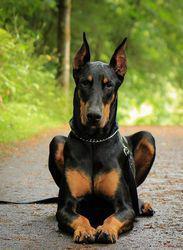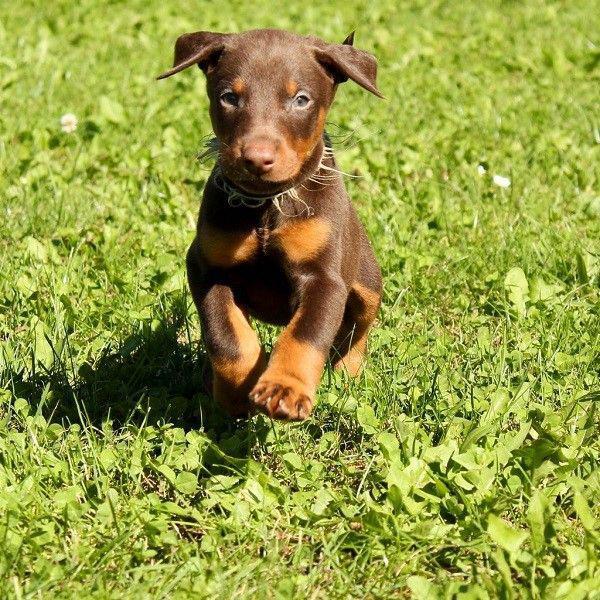The first image is the image on the left, the second image is the image on the right. Examine the images to the left and right. Is the description "One of the dobermans pictures has a black coat and one has a brown coat." accurate? Answer yes or no. Yes. The first image is the image on the left, the second image is the image on the right. Assess this claim about the two images: "All of the dogs are facing directly to the camera.". Correct or not? Answer yes or no. Yes. 